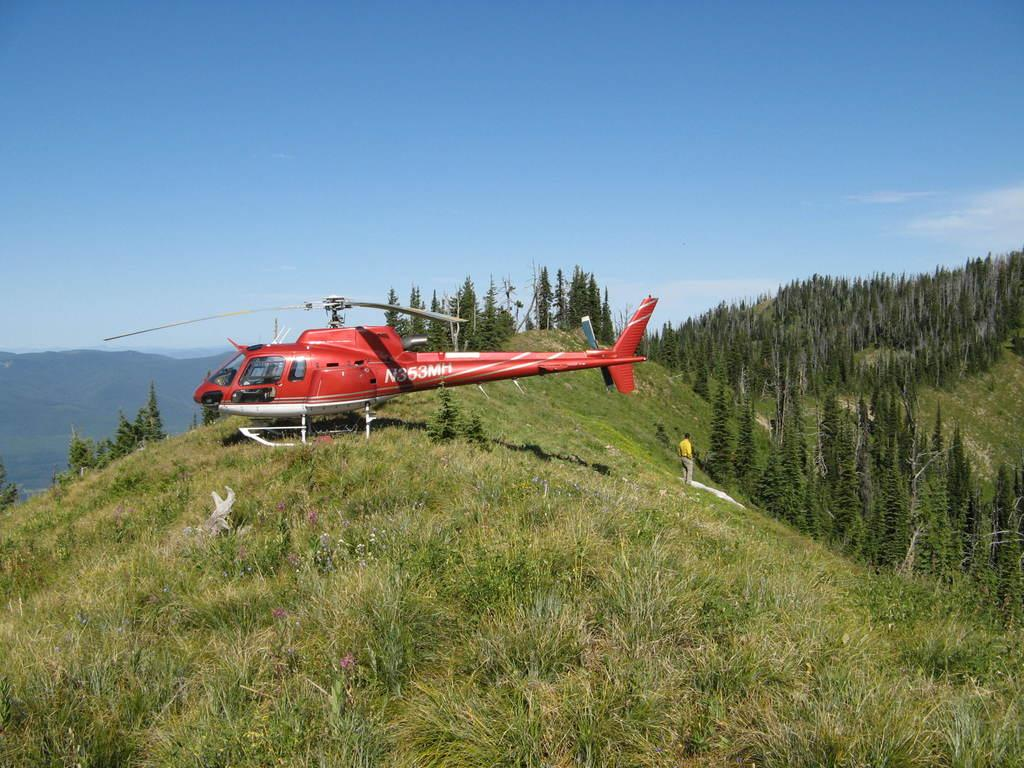What is the main subject of the image? The main subject of the image is a helicopter. What can be seen on the ground in the image? There are plants and a person standing on the ground in the image. What type of vegetation is present in the image? There are trees in the image. What is visible in the background of the image? There are hills and the sky visible in the background of the image. What type of insurance does the helicopter have in the image? There is no information about the helicopter's insurance in the image. 